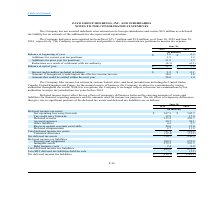According to Zayo Group Holdings's financial document, Where does the company file income tax returns? in various federal, state, and local jurisdictions including the United States, Canada, United Kingdom and France.. The document states: "The Company files income tax returns in various federal, state, and local jurisdictions including the United States, Canada, United Kingdom and France..." Also, How much gross unrecognized tax benefits did the company have as of June 30, 2019? According to the financial document, $15.7 million. The relevant text states: "The Company had gross unrecognized tax benefits of $15.7 million and $3.0 million, as of June 30, 2019 and June 30,..." Also, Which years is the company no longer subject to income tax examinations by tax authorities in major tax jurisdictions? for years before 2014. The document states: "ons by tax authorities in major tax jurisdictions for years before 2014...." Also, can you calculate: What is the % change in the balance at end of year from 2018 to 2019? To answer this question, I need to perform calculations using the financial data. The calculation is: (15.7-3.0)/3.0, which equals 423.33 (percentage). This is based on the information: "s unrecognized tax benefits of $15.7 million and $3.0 million, as of June 30, 2019 and June 30, e Company had gross unrecognized tax benefits of $15.7 million and $3.0 million, as of June 30, 2019 and..." The key data points involved are: 15.7, 3.0. Also, can you calculate: What is the average beginning balance for the years 2018 to 2019? To answer this question, I need to perform calculations using the financial data. The calculation is: (3.0+0.2)/(2019-2018+1), which equals 1.6 (in millions). This is based on the information: "s unrecognized tax benefits of $15.7 million and $3.0 million, as of June 30, 2019 and June 30, Balance at beginning of year $ 3.0 $ 0.2..." The key data points involved are: 0.2, 3.0. Additionally, Which years had additions for current year tax positions of more than 1.1 million? The document shows two values: 2018 and 2019. From the document: "2019 2018 2019 2018..." 